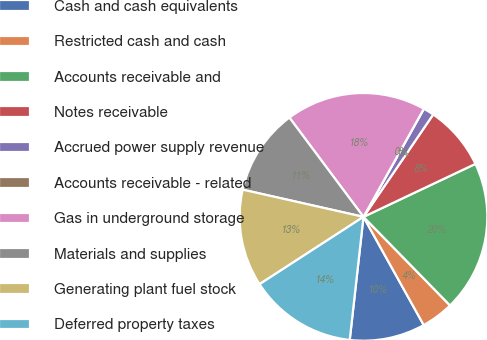Convert chart. <chart><loc_0><loc_0><loc_500><loc_500><pie_chart><fcel>Cash and cash equivalents<fcel>Restricted cash and cash<fcel>Accounts receivable and<fcel>Notes receivable<fcel>Accrued power supply revenue<fcel>Accounts receivable - related<fcel>Gas in underground storage<fcel>Materials and supplies<fcel>Generating plant fuel stock<fcel>Deferred property taxes<nl><fcel>9.86%<fcel>4.23%<fcel>19.72%<fcel>8.45%<fcel>1.41%<fcel>0.0%<fcel>18.31%<fcel>11.27%<fcel>12.68%<fcel>14.08%<nl></chart> 